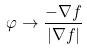<formula> <loc_0><loc_0><loc_500><loc_500>\varphi \rightarrow \frac { - \nabla f } { | \nabla f | }</formula> 